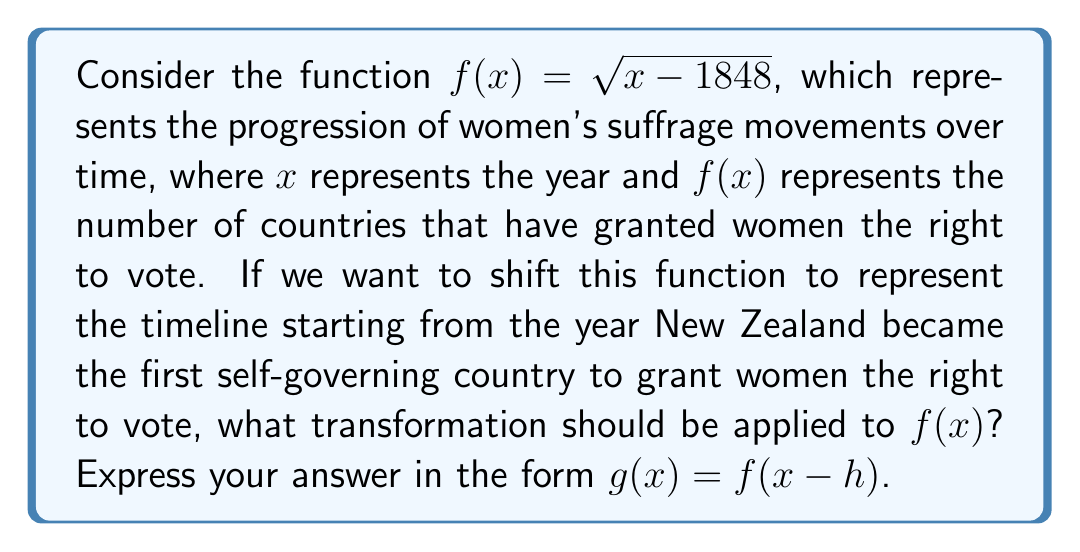Provide a solution to this math problem. To solve this problem, we need to follow these steps:

1. Identify the year New Zealand granted women the right to vote: 1893.

2. Determine the horizontal shift needed:
   - The original function $f(x) = \sqrt{x - 1848}$ has its "starting point" at 1848.
   - We want to shift this to start at 1893.
   - The shift is to the right, and the magnitude is: 1893 - 1848 = 45 years.

3. Apply the transformation:
   - To shift a function $h$ units to the right, we replace $x$ with $(x - h)$.
   - In this case, $h = 45$.

4. Write the new function:
   $g(x) = f(x - 45)$

5. Expand this to get the full form of $g(x)$:
   $g(x) = \sqrt{(x - 45) - 1848} = \sqrt{x - 1893}$

This transformation shifts the entire timeline of women's suffrage movements 45 years to the right, aligning the "start" with the significant milestone of New Zealand granting women the right to vote.
Answer: $g(x) = f(x - 45)$ 